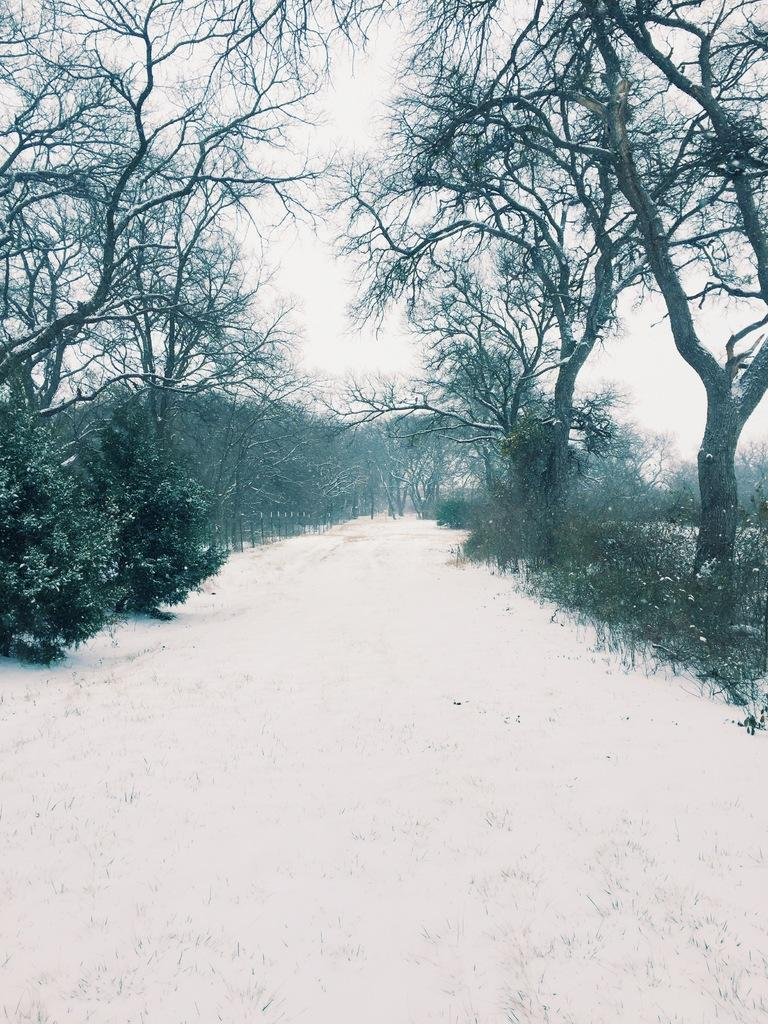What type of vegetation is present in the image? There are trees with branches and leaves in the image. How is the vegetation affected in the image? The trees appear to be covered in snow. Are there any other types of plants visible in the image? Yes, there are plants in the image. What can be seen in the background of the image? The sky is visible in the image. What type of prose is being recited by the trees in the image? There is no indication in the image that the trees are reciting any prose. What kind of bread can be seen hanging from the branches of the trees in the image? There is no bread present in the image; it features trees covered in snow. 